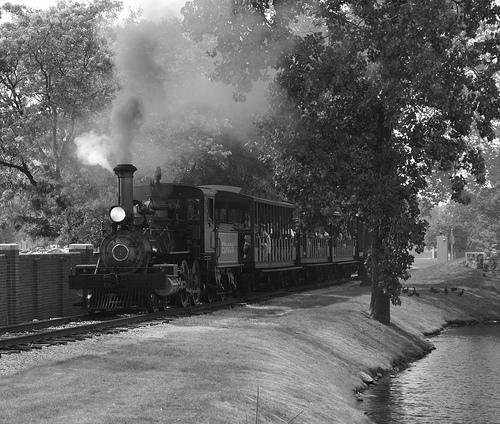Question: where is the light?
Choices:
A. On top of the desk.
B. Behind the curtain.
C. Front of train.
D. In the fish tank.
Answer with the letter. Answer: C Question: what kind of photo is this?
Choices:
A. Color.
B. Black and white.
C. Action.
D. Scenary.
Answer with the letter. Answer: B Question: how does the engine appear to be powered?
Choices:
A. Gas.
B. Steam.
C. Electric.
D. Water.
Answer with the letter. Answer: B Question: where are the passenger cars?
Choices:
A. On the track.
B. In the roundhouse.
C. Behind the engine.
D. Before the caboose.
Answer with the letter. Answer: C Question: where is the wall?
Choices:
A. Below the ceiling.
B. Above the floor.
C. Before the door.
D. Left side of picture.
Answer with the letter. Answer: D 